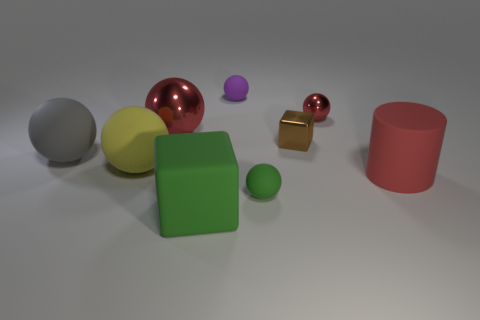Subtract all big gray rubber spheres. How many spheres are left? 5 Subtract all purple cylinders. How many red spheres are left? 2 Add 1 small purple cubes. How many objects exist? 10 Subtract all green spheres. How many spheres are left? 5 Subtract all cylinders. How many objects are left? 8 Subtract all cyan balls. Subtract all blue cylinders. How many balls are left? 6 Add 8 small red matte things. How many small red matte things exist? 8 Subtract 0 blue spheres. How many objects are left? 9 Subtract all yellow matte cylinders. Subtract all red rubber things. How many objects are left? 8 Add 5 shiny blocks. How many shiny blocks are left? 6 